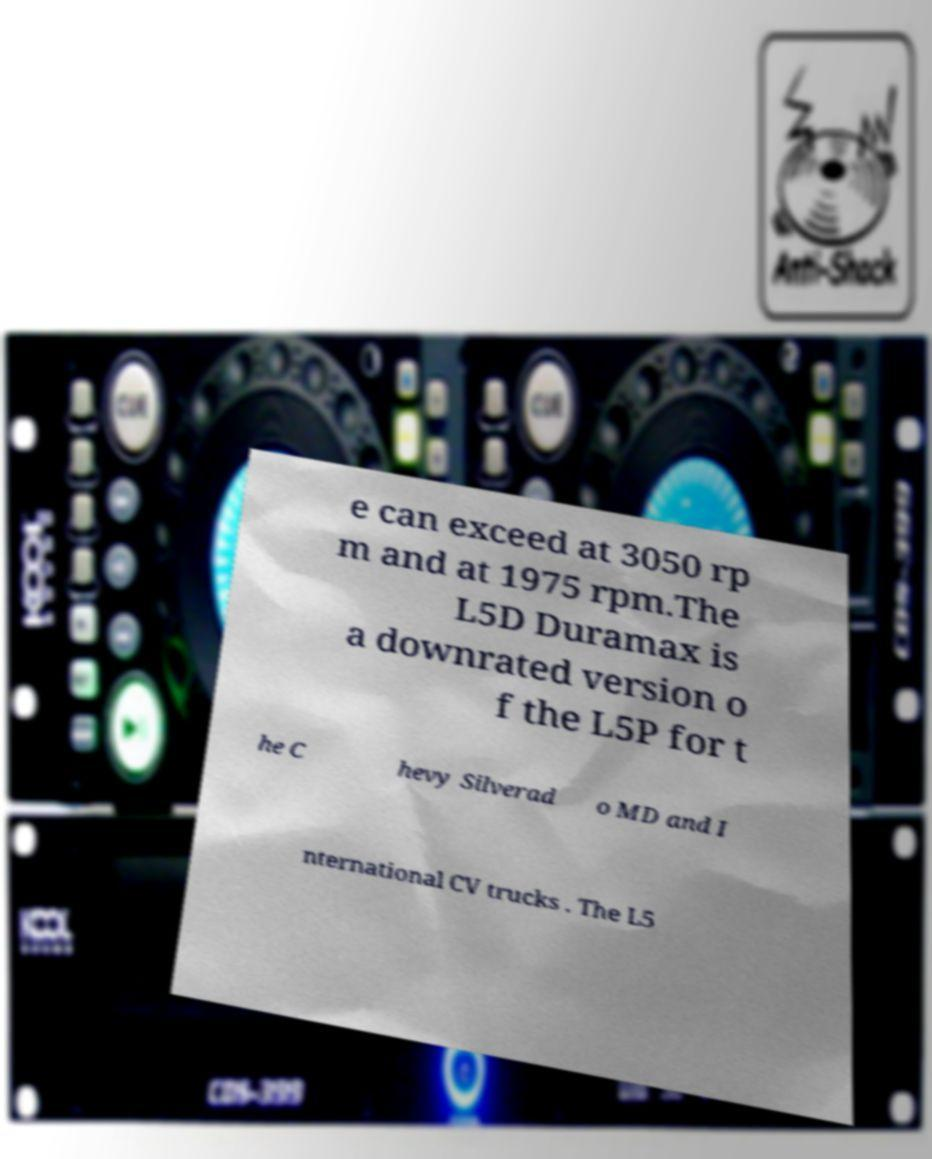I need the written content from this picture converted into text. Can you do that? e can exceed at 3050 rp m and at 1975 rpm.The L5D Duramax is a downrated version o f the L5P for t he C hevy Silverad o MD and I nternational CV trucks . The L5 